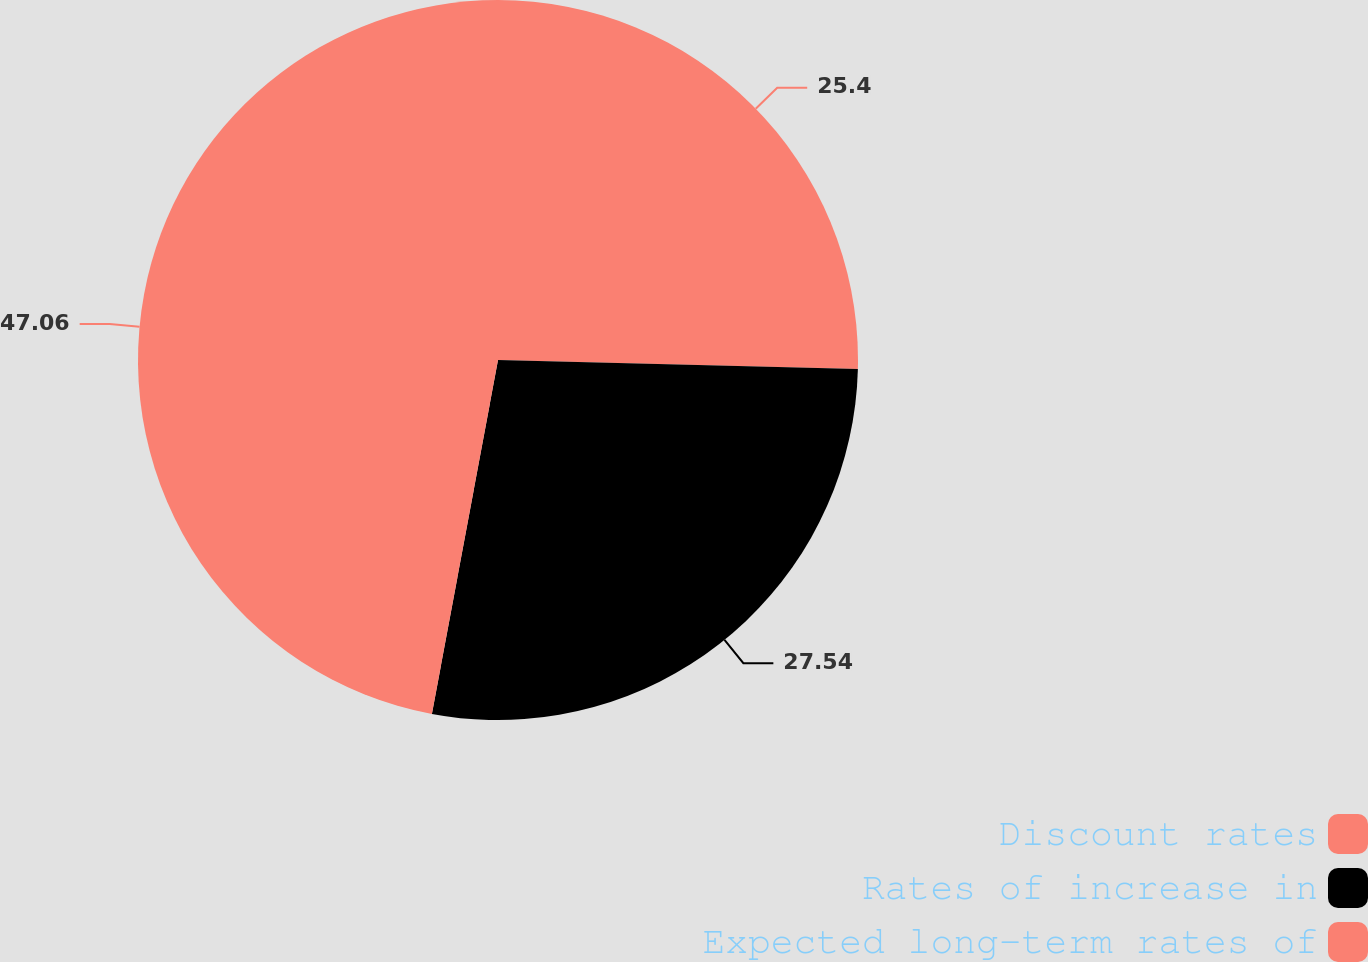<chart> <loc_0><loc_0><loc_500><loc_500><pie_chart><fcel>Discount rates<fcel>Rates of increase in<fcel>Expected long-term rates of<nl><fcel>25.4%<fcel>27.54%<fcel>47.06%<nl></chart> 